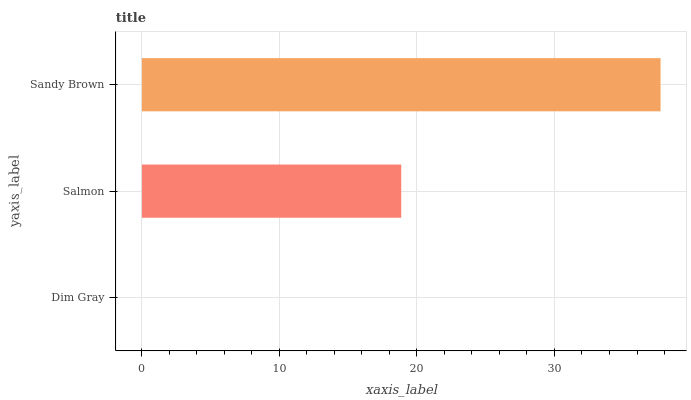Is Dim Gray the minimum?
Answer yes or no. Yes. Is Sandy Brown the maximum?
Answer yes or no. Yes. Is Salmon the minimum?
Answer yes or no. No. Is Salmon the maximum?
Answer yes or no. No. Is Salmon greater than Dim Gray?
Answer yes or no. Yes. Is Dim Gray less than Salmon?
Answer yes or no. Yes. Is Dim Gray greater than Salmon?
Answer yes or no. No. Is Salmon less than Dim Gray?
Answer yes or no. No. Is Salmon the high median?
Answer yes or no. Yes. Is Salmon the low median?
Answer yes or no. Yes. Is Sandy Brown the high median?
Answer yes or no. No. Is Dim Gray the low median?
Answer yes or no. No. 